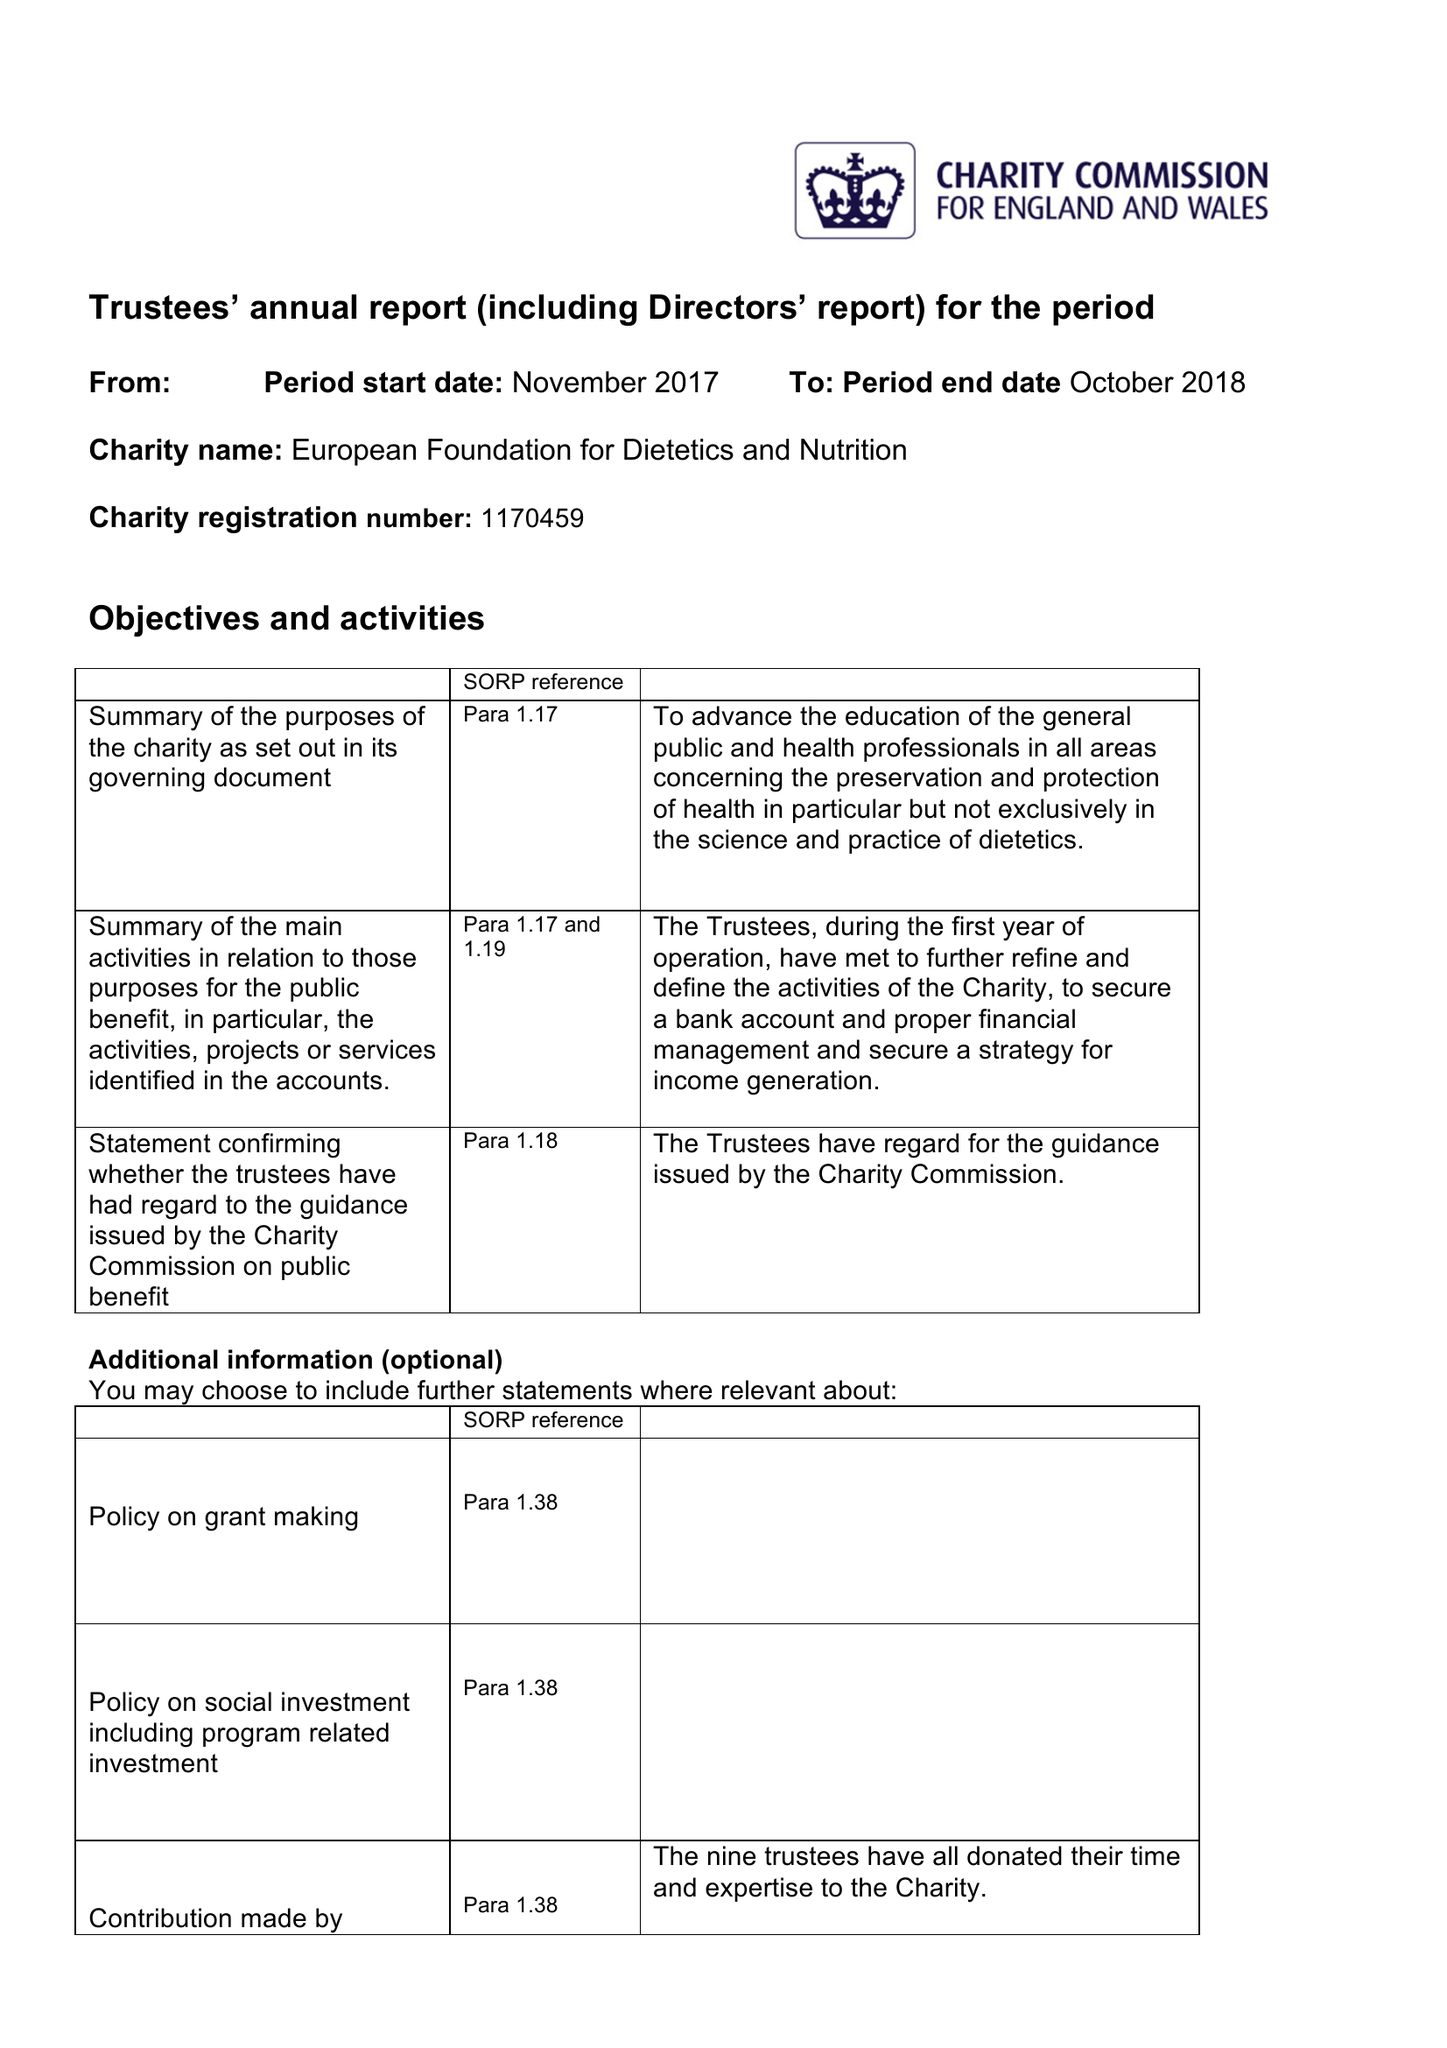What is the value for the income_annually_in_british_pounds?
Answer the question using a single word or phrase. 4494.00 